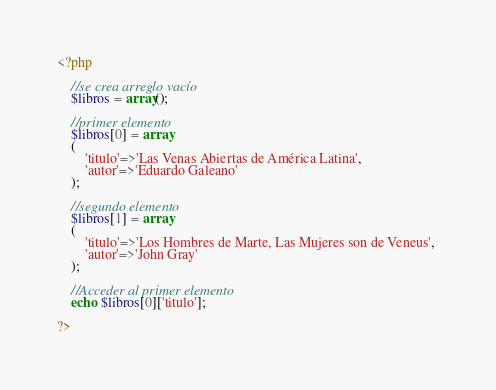<code> <loc_0><loc_0><loc_500><loc_500><_PHP_><?php
	
	//se crea arreglo vacío
	$libros = array();

	//primer elemento
	$libros[0] = array
	(
		'titulo'=>'Las Venas Abiertas de América Latina', 
		'autor'=>'Eduardo Galeano'
	);

	//segundo elemento
	$libros[1] = array
	(
		'titulo'=>'Los Hombres de Marte, Las Mujeres son de Veneus', 
		'autor'=>'John Gray'
	);

	//Acceder al primer elemento
	echo $libros[0]['titulo'];

?></code> 